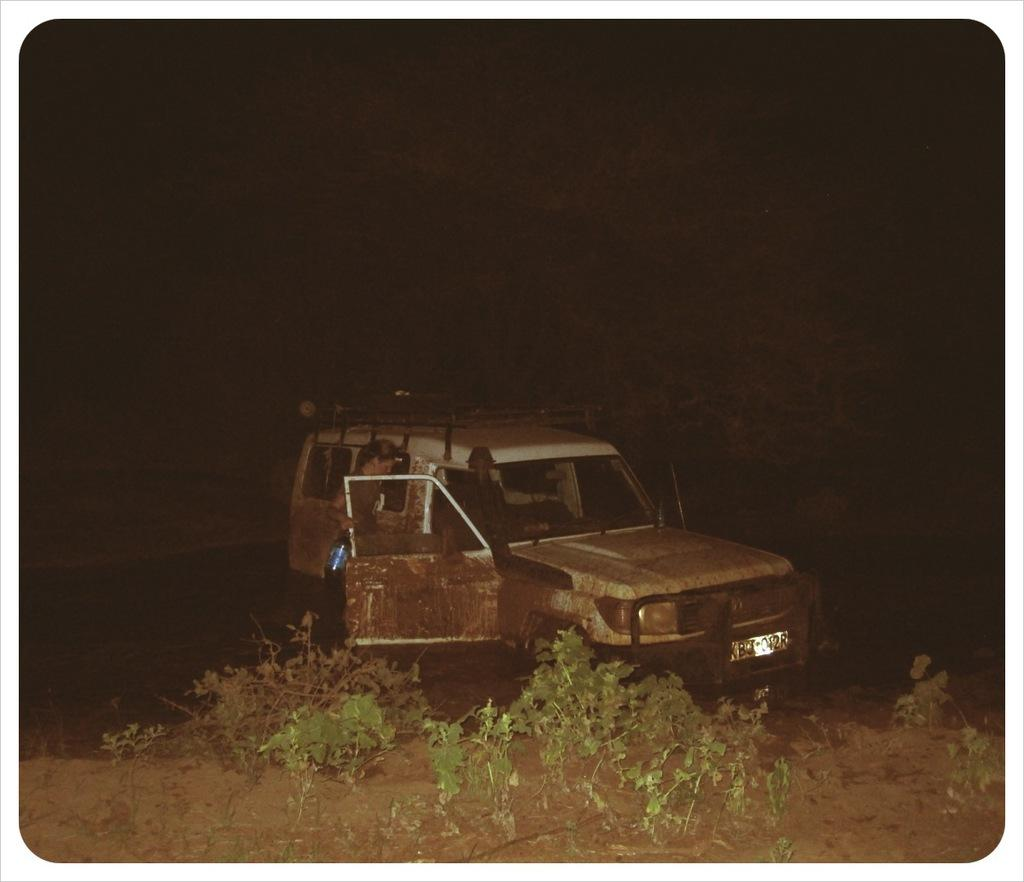What is the main subject of the image? The main subject of the image is a vehicle. Can you describe the lady in the image? There is a lady holding a bottle in the image. What type of vegetation is visible in the image? There are plants in the front of the image. How would you describe the lighting in the image? The background of the image is dark. Can you tell me how many wounds are visible on the vehicle in the image? There are no wounds visible on the vehicle in the image. Is there a faucet present in the image? There is no faucet present in the image. 